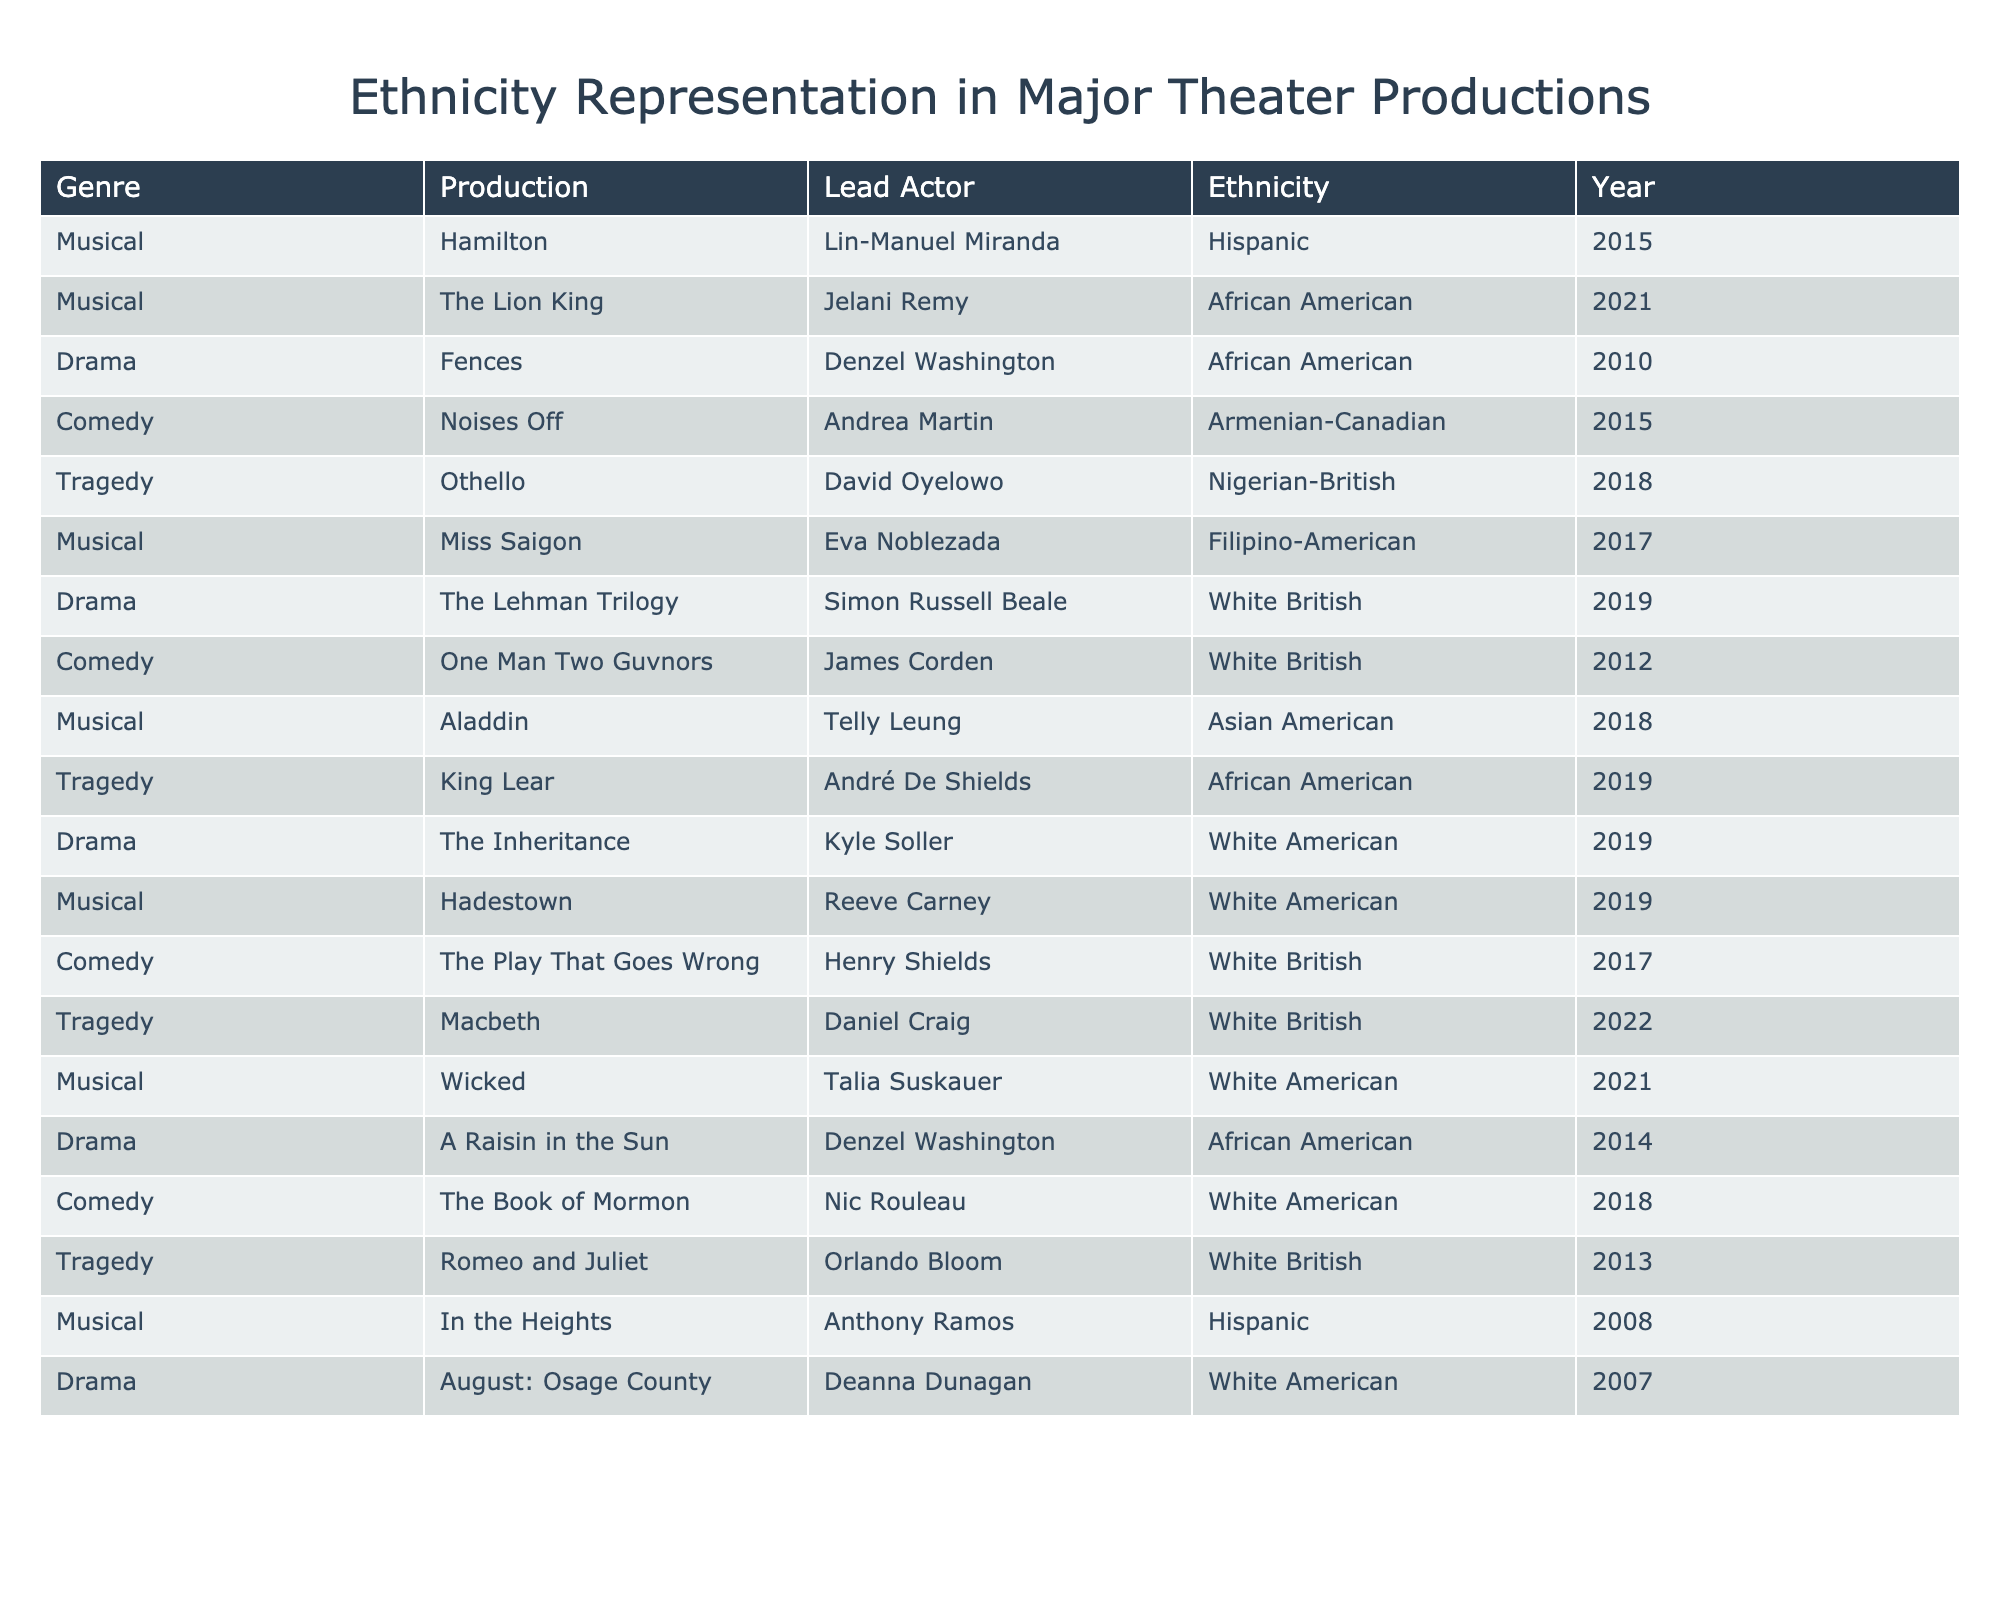What is the genre of the production "Hamilton"? The table lists the production "Hamilton" under the column "Genre," which states it is a musical.
Answer: Musical Who played the lead role in "Fences"? The table shows that Denzel Washington played the lead role in "Fences."
Answer: Denzel Washington How many productions feature a lead actor of African American ethnicity? By counting the entries in the "Ethnicity" column where the value is "African American," we find 4 productions: "Fences," "King Lear," "A Raisin in the Sun," and "The Lion King."
Answer: 4 Which production has a lead actor of Filipino-American ethnicity? The table indicates that the lead actor in "Miss Saigon" is Eva Noblezada, who is Filipino-American.
Answer: Miss Saigon Are there more musical productions than dramas in this list? By counting, there are 8 musical productions and 5 drama productions in the table, so there are more musicals.
Answer: Yes What is the total number of productions featuring lead actors representing Hispanic ethnicity? There are 2 productions featuring Hispanic lead actors: "Hamilton" and "In the Heights." Thus, we sum them to find a total of 2.
Answer: 2 Which year did "Wicked" premiere, and what is the lead actor's ethnicity? The table states that "Wicked" premiered in 2021 and has a lead actor of White American ethnicity.
Answer: 2021, White American Among the productions listed, which genre has the least number of productions? Counting the entries, we find that there are 5 comedy productions, 4 tragedy productions, 8 musicals, and 5 dramas. Tragedy has the least with 4 productions.
Answer: Tragedy Is "The Lion King" the only production featuring an African American lead actor in 2021? Upon reviewing the table, "The Lion King" is the only African American lead actor listed for 2021, which confirms that it is true.
Answer: Yes In how many musical productions is the lead actor of Asian descent? Referring to the table, the Asian descent lead actors are in "Aladdin" and "Miss Saigon," totaling 2 musical productions.
Answer: 2 What is the average year of the productions listed for lead actors of White British ethnicity? The productions with White British lead actors are "The Lehman Trilogy" (2019), "One Man Two Guvnors" (2012), "The Play That Goes Wrong" (2017), "Macbeth" (2022), and "Romeo and Juliet" (2013). The average year is (2019 + 2012 + 2017 + 2022 + 2013) / 5 = 2018.6, rounded to 2019.
Answer: 2019 